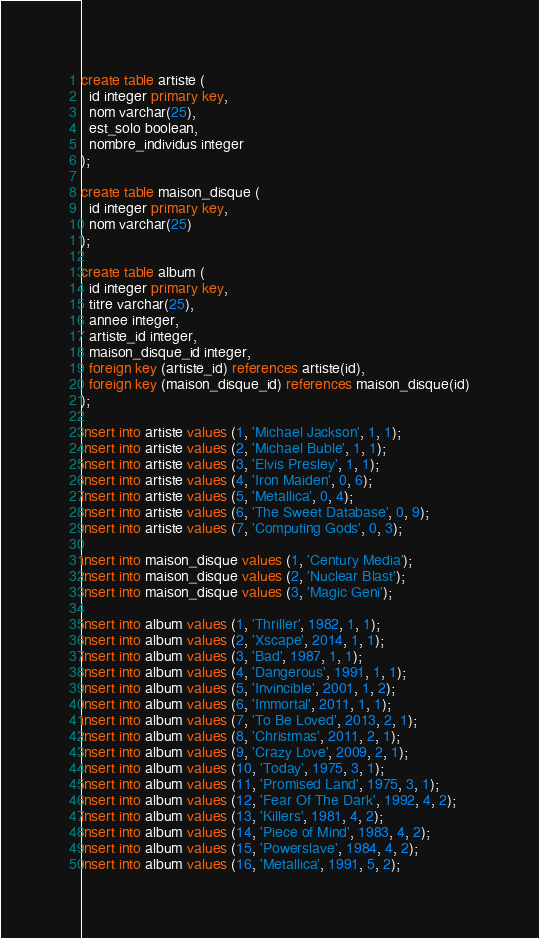<code> <loc_0><loc_0><loc_500><loc_500><_SQL_>create table artiste (
  id integer primary key,
  nom varchar(25),
  est_solo boolean,
  nombre_individus integer
);

create table maison_disque (
  id integer primary key,
  nom varchar(25)
);

create table album (
  id integer primary key,
  titre varchar(25),
  annee integer,
  artiste_id integer,
  maison_disque_id integer,
  foreign key (artiste_id) references artiste(id),
  foreign key (maison_disque_id) references maison_disque(id)
);

insert into artiste values (1, 'Michael Jackson', 1, 1);
insert into artiste values (2, 'Michael Buble', 1, 1);
insert into artiste values (3, 'Elvis Presley', 1, 1);
insert into artiste values (4, 'Iron Maiden', 0, 6);
insert into artiste values (5, 'Metallica', 0, 4);
insert into artiste values (6, 'The Sweet Database', 0, 9);
insert into artiste values (7, 'Computing Gods', 0, 3);

insert into maison_disque values (1, 'Century Media');
insert into maison_disque values (2, 'Nuclear Blast');
insert into maison_disque values (3, 'Magic Geni');

insert into album values (1, 'Thriller', 1982, 1, 1);
insert into album values (2, 'Xscape', 2014, 1, 1);
insert into album values (3, 'Bad', 1987, 1, 1);
insert into album values (4, 'Dangerous', 1991, 1, 1);
insert into album values (5, 'Invincible', 2001, 1, 2);
insert into album values (6, 'Immortal', 2011, 1, 1);
insert into album values (7, 'To Be Loved', 2013, 2, 1);
insert into album values (8, 'Christmas', 2011, 2, 1);
insert into album values (9, 'Crazy Love', 2009, 2, 1);
insert into album values (10, 'Today', 1975, 3, 1);
insert into album values (11, 'Promised Land', 1975, 3, 1);
insert into album values (12, 'Fear Of The Dark', 1992, 4, 2);
insert into album values (13, 'Killers', 1981, 4, 2);
insert into album values (14, 'Piece of Mind', 1983, 4, 2);
insert into album values (15, 'Powerslave', 1984, 4, 2);
insert into album values (16, 'Metallica', 1991, 5, 2);</code> 